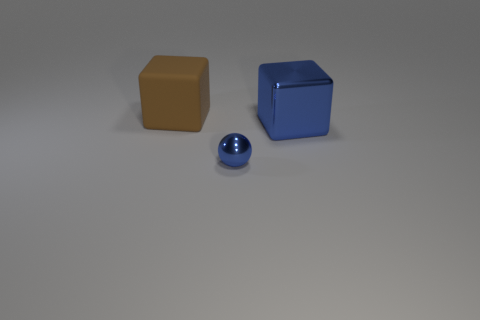Add 2 large purple metal balls. How many objects exist? 5 Subtract all blue blocks. How many blocks are left? 1 Subtract all balls. How many objects are left? 2 Add 3 brown rubber objects. How many brown rubber objects are left? 4 Add 2 small shiny objects. How many small shiny objects exist? 3 Subtract 0 blue cylinders. How many objects are left? 3 Subtract 1 blocks. How many blocks are left? 1 Subtract all green blocks. Subtract all yellow cylinders. How many blocks are left? 2 Subtract all red blocks. How many purple spheres are left? 0 Subtract all green rubber things. Subtract all metal cubes. How many objects are left? 2 